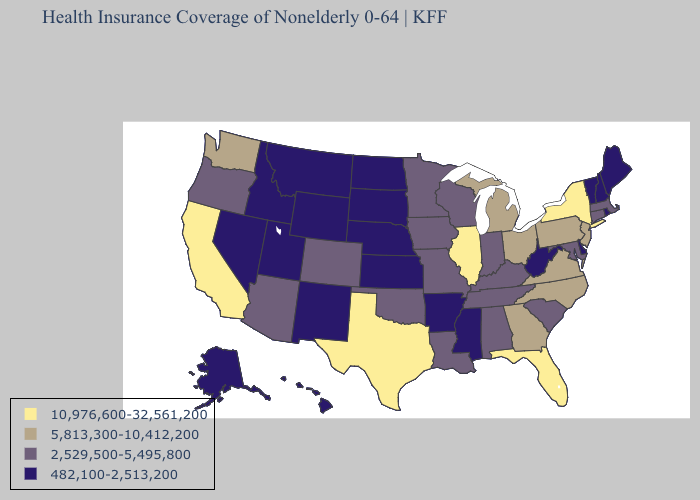Does West Virginia have a lower value than New Mexico?
Quick response, please. No. What is the highest value in the South ?
Quick response, please. 10,976,600-32,561,200. Does Wisconsin have a lower value than California?
Give a very brief answer. Yes. Name the states that have a value in the range 5,813,300-10,412,200?
Quick response, please. Georgia, Michigan, New Jersey, North Carolina, Ohio, Pennsylvania, Virginia, Washington. What is the value of Pennsylvania?
Short answer required. 5,813,300-10,412,200. Does California have the highest value in the West?
Give a very brief answer. Yes. Does Pennsylvania have the highest value in the USA?
Concise answer only. No. What is the value of Nevada?
Keep it brief. 482,100-2,513,200. Does Maryland have the lowest value in the USA?
Be succinct. No. What is the highest value in states that border Michigan?
Short answer required. 5,813,300-10,412,200. Name the states that have a value in the range 10,976,600-32,561,200?
Be succinct. California, Florida, Illinois, New York, Texas. What is the value of New Mexico?
Answer briefly. 482,100-2,513,200. What is the value of Oregon?
Keep it brief. 2,529,500-5,495,800. What is the value of Wyoming?
Concise answer only. 482,100-2,513,200. What is the value of Tennessee?
Quick response, please. 2,529,500-5,495,800. 